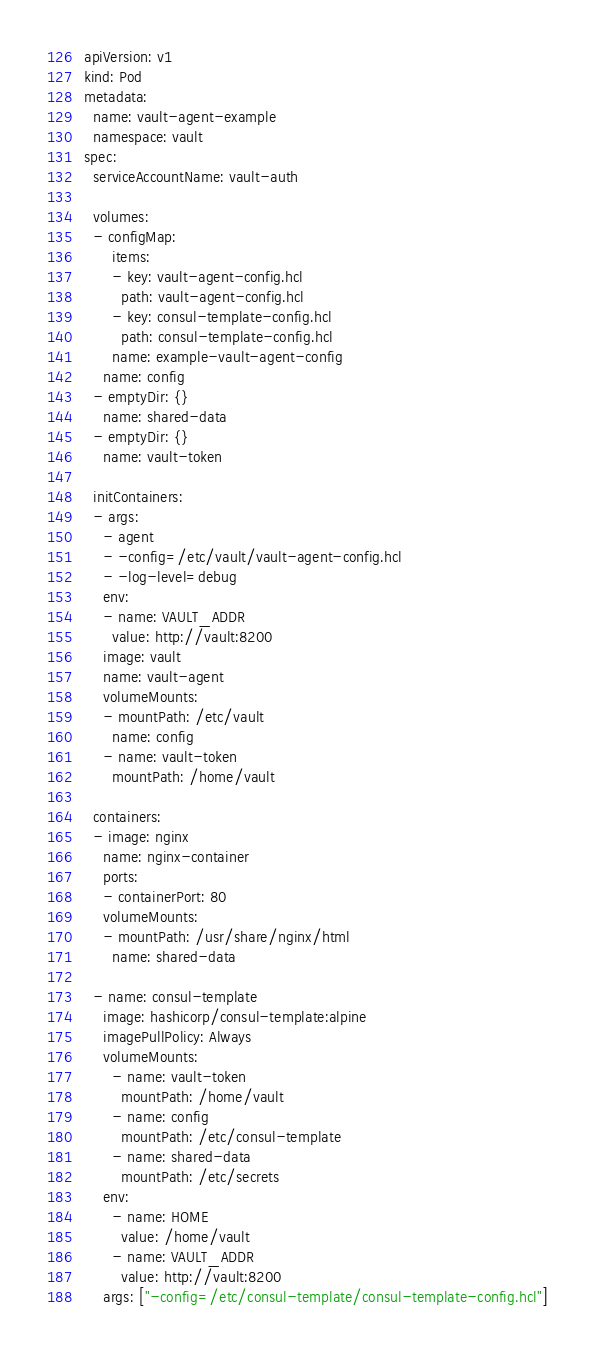<code> <loc_0><loc_0><loc_500><loc_500><_YAML_>apiVersion: v1
kind: Pod
metadata:
  name: vault-agent-example
  namespace: vault
spec:
  serviceAccountName: vault-auth

  volumes:
  - configMap:
      items:
      - key: vault-agent-config.hcl
        path: vault-agent-config.hcl
      - key: consul-template-config.hcl
        path: consul-template-config.hcl
      name: example-vault-agent-config
    name: config
  - emptyDir: {}
    name: shared-data
  - emptyDir: {}
    name: vault-token    

  initContainers:
  - args:
    - agent
    - -config=/etc/vault/vault-agent-config.hcl
    - -log-level=debug
    env:
    - name: VAULT_ADDR
      value: http://vault:8200
    image: vault
    name: vault-agent
    volumeMounts:
    - mountPath: /etc/vault
      name: config
    - name: vault-token
      mountPath: /home/vault

  containers:
  - image: nginx
    name: nginx-container
    ports:
    - containerPort: 80
    volumeMounts:
    - mountPath: /usr/share/nginx/html
      name: shared-data

  - name: consul-template
    image: hashicorp/consul-template:alpine
    imagePullPolicy: Always
    volumeMounts:
      - name: vault-token
        mountPath: /home/vault
      - name: config
        mountPath: /etc/consul-template
      - name: shared-data
        mountPath: /etc/secrets
    env:
      - name: HOME
        value: /home/vault
      - name: VAULT_ADDR
        value: http://vault:8200
    args: ["-config=/etc/consul-template/consul-template-config.hcl"]
</code> 